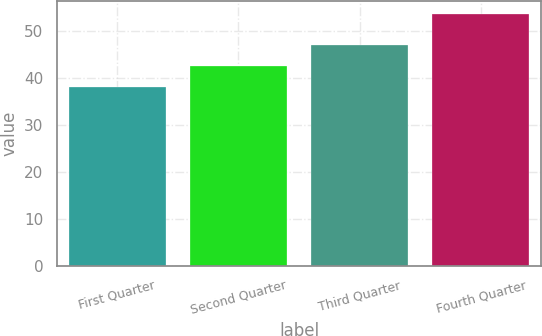Convert chart to OTSL. <chart><loc_0><loc_0><loc_500><loc_500><bar_chart><fcel>First Quarter<fcel>Second Quarter<fcel>Third Quarter<fcel>Fourth Quarter<nl><fcel>37.95<fcel>42.54<fcel>46.87<fcel>53.54<nl></chart> 